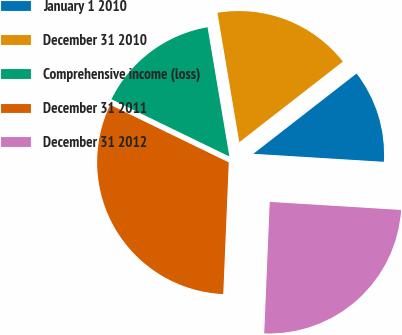<chart> <loc_0><loc_0><loc_500><loc_500><pie_chart><fcel>January 1 2010<fcel>December 31 2010<fcel>Comprehensive income (loss)<fcel>December 31 2011<fcel>December 31 2012<nl><fcel>11.5%<fcel>17.14%<fcel>15.14%<fcel>31.53%<fcel>24.69%<nl></chart> 